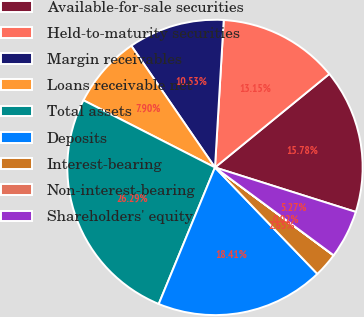<chart> <loc_0><loc_0><loc_500><loc_500><pie_chart><fcel>Available-for-sale securities<fcel>Held-to-maturity securities<fcel>Margin receivables<fcel>Loans receivable net<fcel>Total assets<fcel>Deposits<fcel>Interest-bearing<fcel>Non-interest-bearing<fcel>Shareholders' equity<nl><fcel>15.78%<fcel>13.15%<fcel>10.53%<fcel>7.9%<fcel>26.29%<fcel>18.41%<fcel>2.65%<fcel>0.02%<fcel>5.27%<nl></chart> 